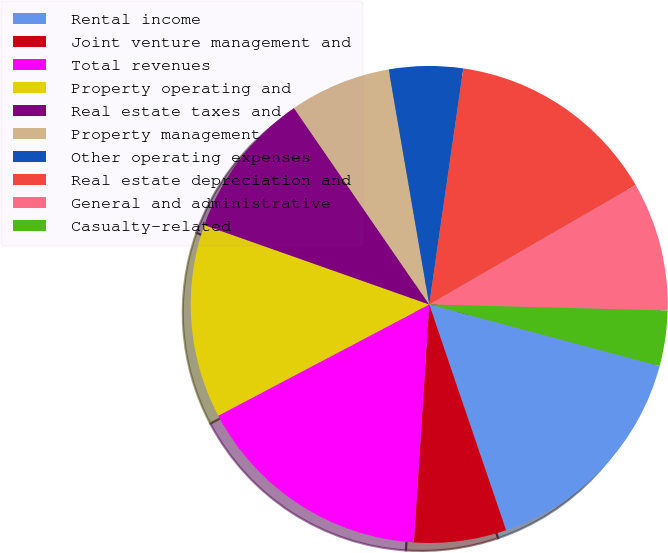<chart> <loc_0><loc_0><loc_500><loc_500><pie_chart><fcel>Rental income<fcel>Joint venture management and<fcel>Total revenues<fcel>Property operating and<fcel>Real estate taxes and<fcel>Property management<fcel>Other operating expenses<fcel>Real estate depreciation and<fcel>General and administrative<fcel>Casualty-related<nl><fcel>15.62%<fcel>6.25%<fcel>16.25%<fcel>13.12%<fcel>10.0%<fcel>6.88%<fcel>5.0%<fcel>14.37%<fcel>8.75%<fcel>3.75%<nl></chart> 